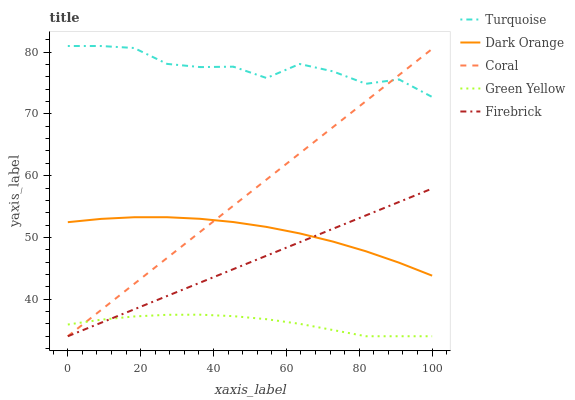Does Green Yellow have the minimum area under the curve?
Answer yes or no. Yes. Does Turquoise have the maximum area under the curve?
Answer yes or no. Yes. Does Dark Orange have the minimum area under the curve?
Answer yes or no. No. Does Dark Orange have the maximum area under the curve?
Answer yes or no. No. Is Firebrick the smoothest?
Answer yes or no. Yes. Is Turquoise the roughest?
Answer yes or no. Yes. Is Dark Orange the smoothest?
Answer yes or no. No. Is Dark Orange the roughest?
Answer yes or no. No. Does Firebrick have the lowest value?
Answer yes or no. Yes. Does Dark Orange have the lowest value?
Answer yes or no. No. Does Turquoise have the highest value?
Answer yes or no. Yes. Does Dark Orange have the highest value?
Answer yes or no. No. Is Dark Orange less than Turquoise?
Answer yes or no. Yes. Is Turquoise greater than Dark Orange?
Answer yes or no. Yes. Does Coral intersect Green Yellow?
Answer yes or no. Yes. Is Coral less than Green Yellow?
Answer yes or no. No. Is Coral greater than Green Yellow?
Answer yes or no. No. Does Dark Orange intersect Turquoise?
Answer yes or no. No. 